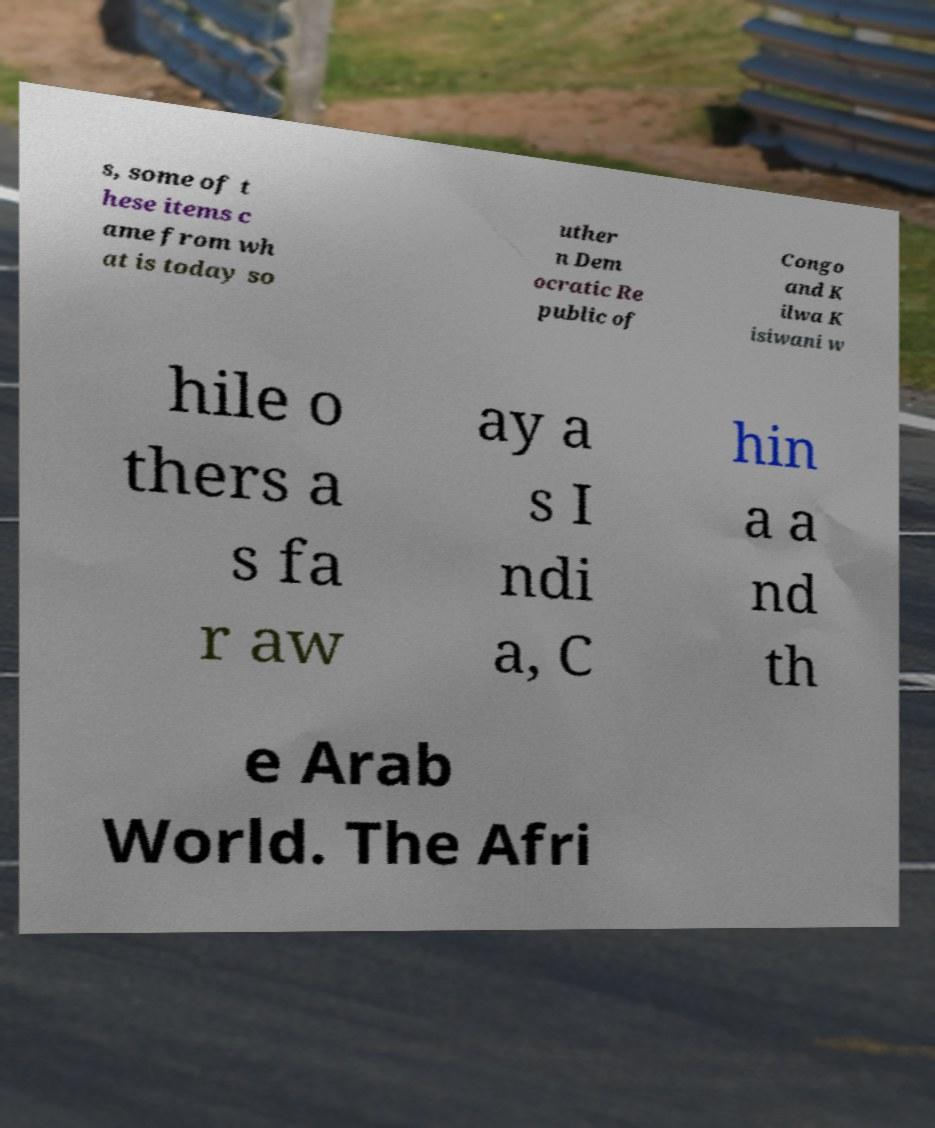Could you extract and type out the text from this image? s, some of t hese items c ame from wh at is today so uther n Dem ocratic Re public of Congo and K ilwa K isiwani w hile o thers a s fa r aw ay a s I ndi a, C hin a a nd th e Arab World. The Afri 